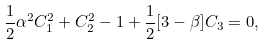Convert formula to latex. <formula><loc_0><loc_0><loc_500><loc_500>\frac { 1 } { 2 } \alpha ^ { 2 } C ^ { 2 } _ { 1 } + C ^ { 2 } _ { 2 } - 1 + \frac { 1 } { 2 } [ 3 - \beta ] C _ { 3 } = 0 ,</formula> 